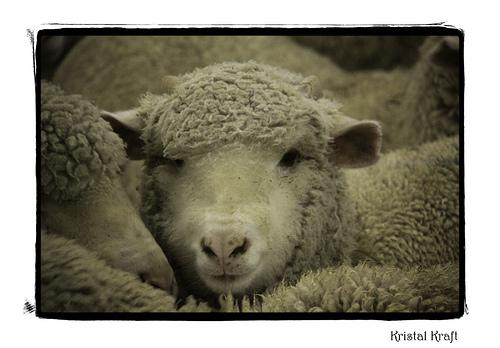What sound will he make? baa 